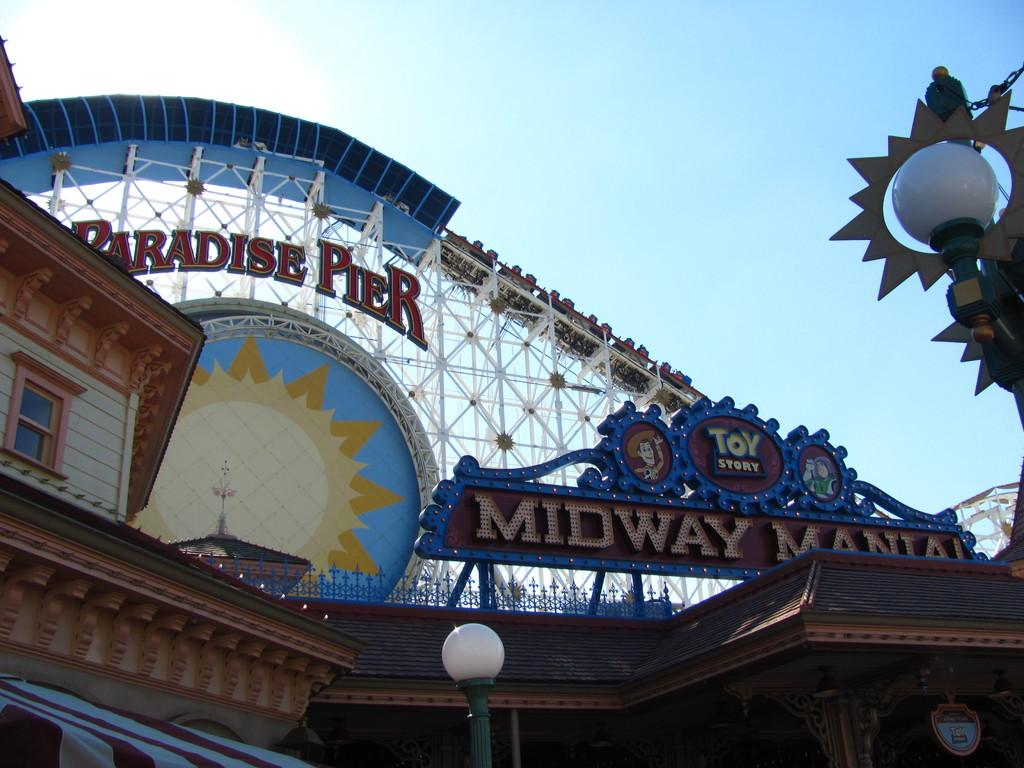Provide a one-sentence caption for the provided image. People ride a wooden roller coaster at Paradise Pier. 